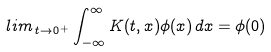<formula> <loc_0><loc_0><loc_500><loc_500>l i m \, _ { t \rightarrow 0 ^ { + } } \int _ { - \infty } ^ { \infty } K ( t , x ) \phi ( x ) \, d x = \phi ( 0 )</formula> 